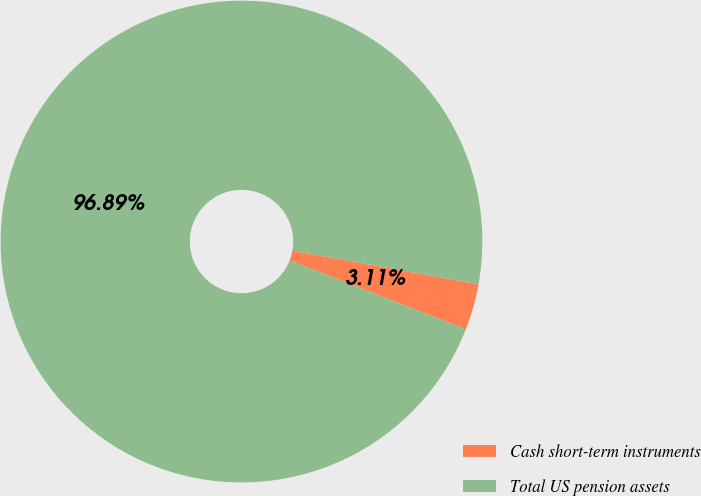Convert chart to OTSL. <chart><loc_0><loc_0><loc_500><loc_500><pie_chart><fcel>Cash short-term instruments<fcel>Total US pension assets<nl><fcel>3.11%<fcel>96.89%<nl></chart> 